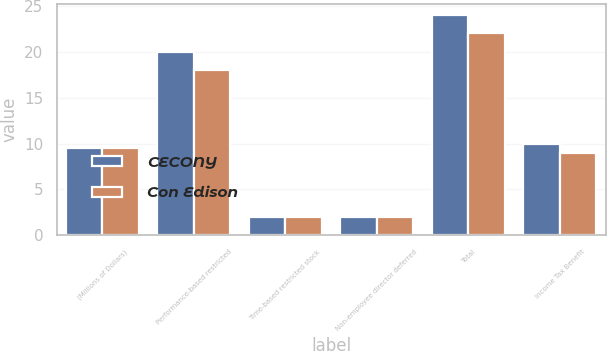Convert chart. <chart><loc_0><loc_0><loc_500><loc_500><stacked_bar_chart><ecel><fcel>(Millions of Dollars)<fcel>Performance-based restricted<fcel>Time-based restricted stock<fcel>Non-employee director deferred<fcel>Total<fcel>Income Tax Benefit<nl><fcel>CECONY<fcel>9.5<fcel>20<fcel>2<fcel>2<fcel>24<fcel>10<nl><fcel>Con Edison<fcel>9.5<fcel>18<fcel>2<fcel>2<fcel>22<fcel>9<nl></chart> 